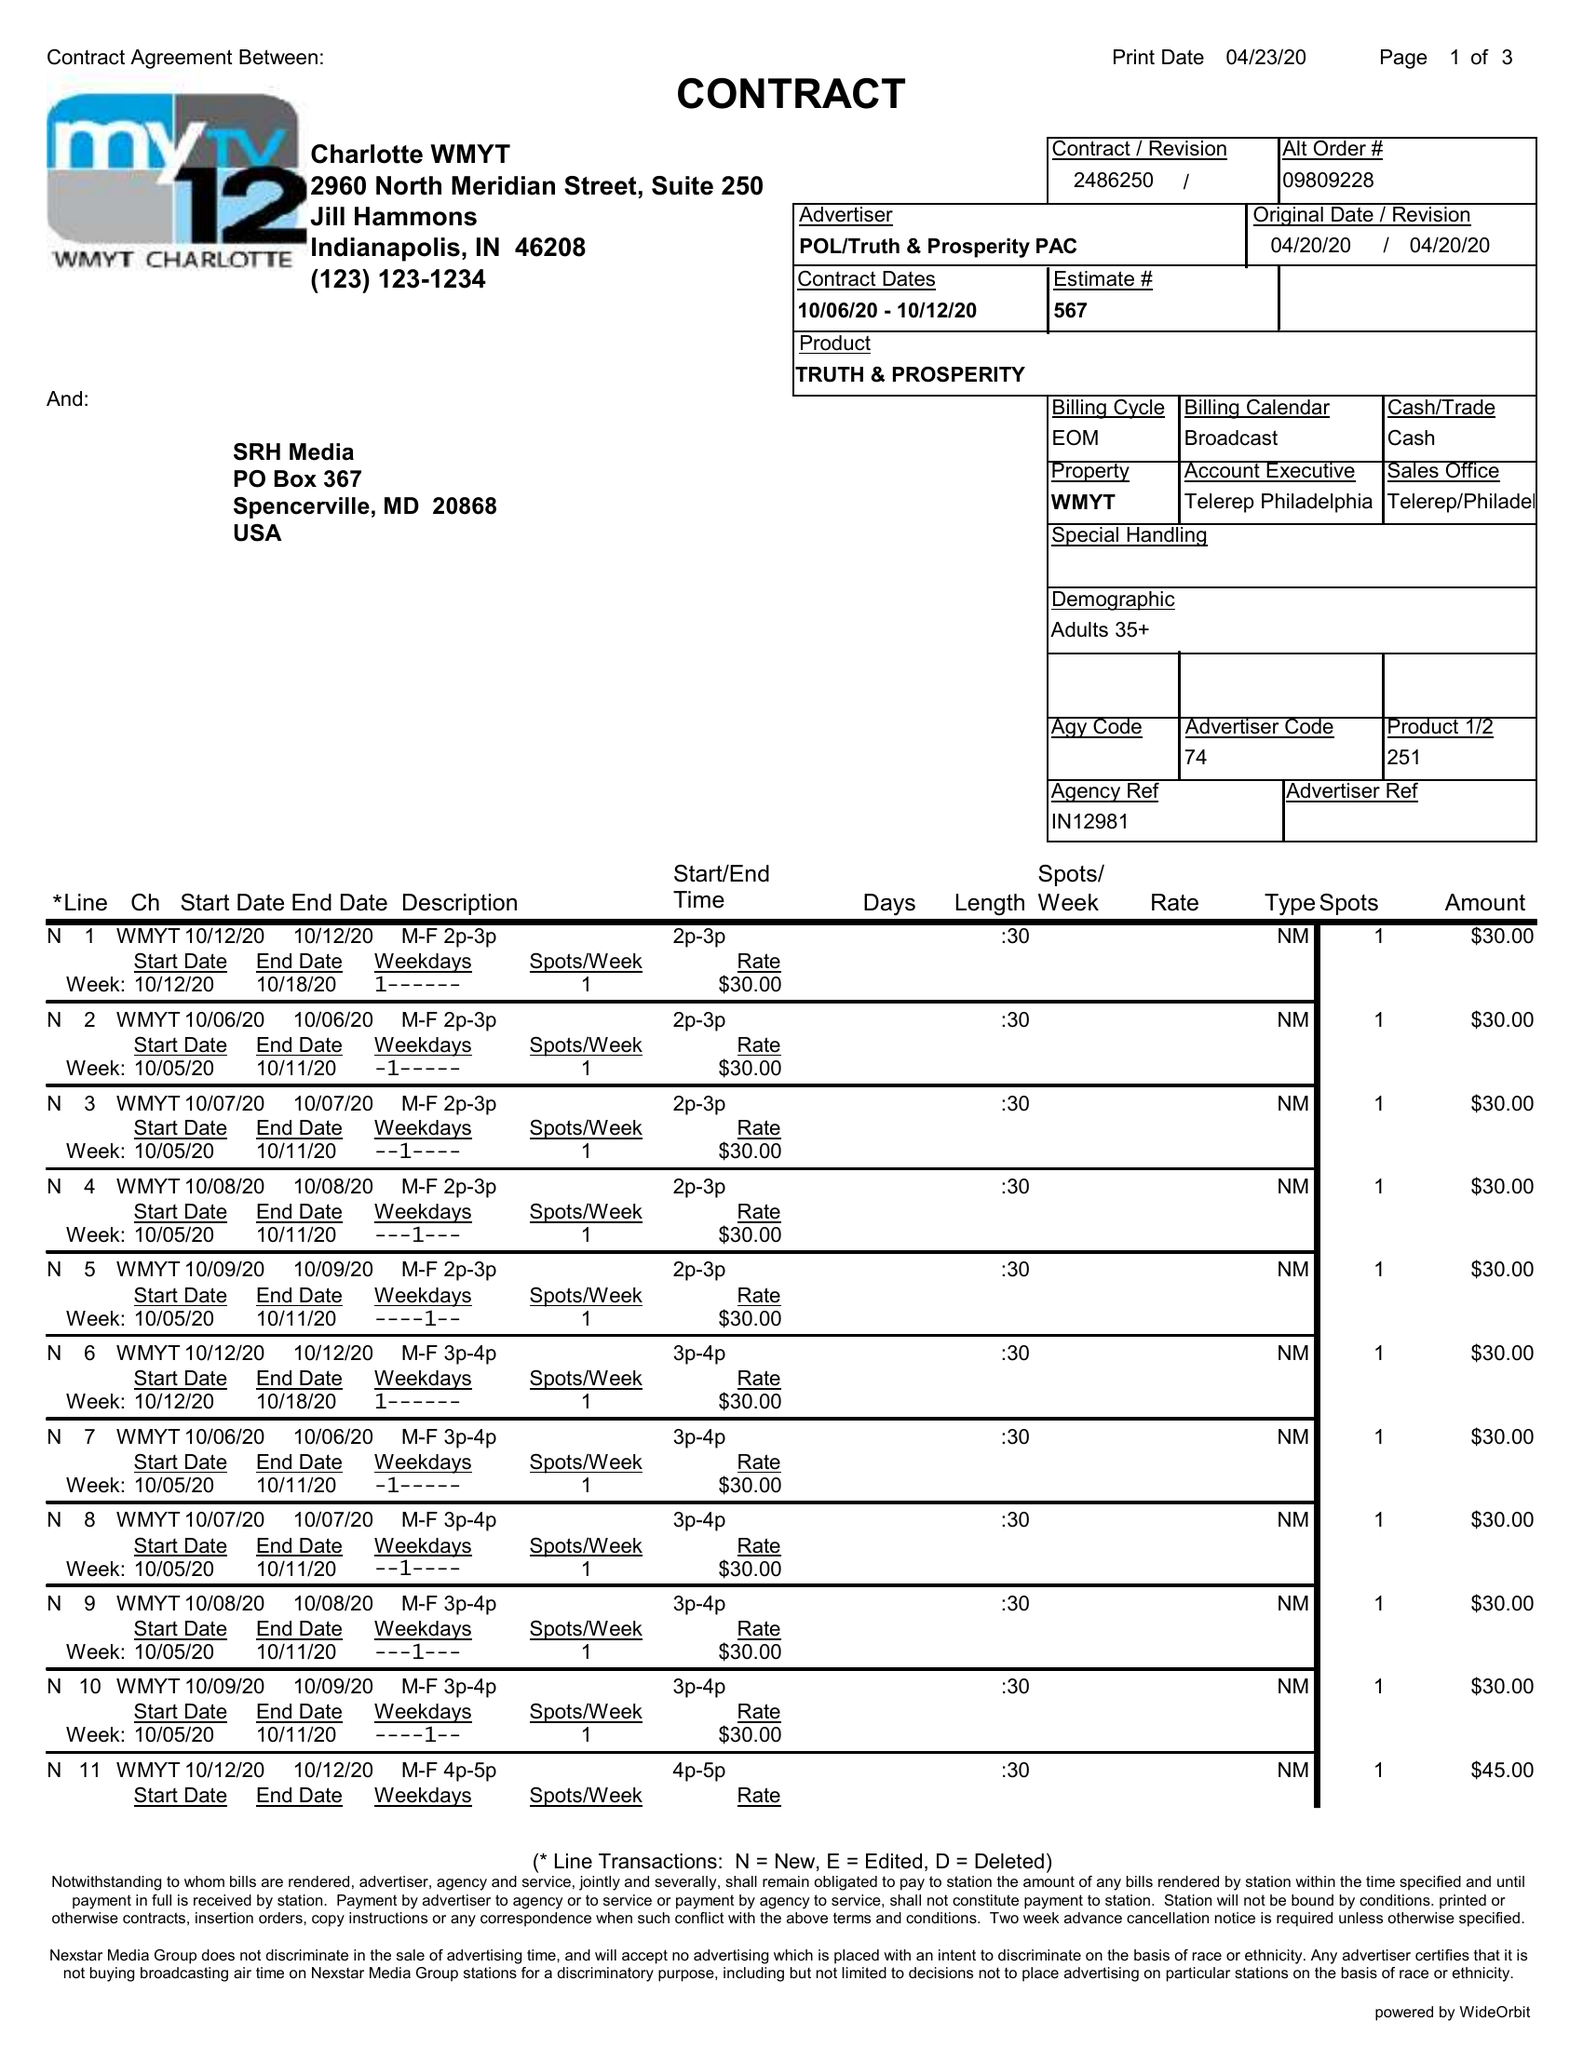What is the value for the advertiser?
Answer the question using a single word or phrase. POL/TRUTH&PROSPERITYPAC 